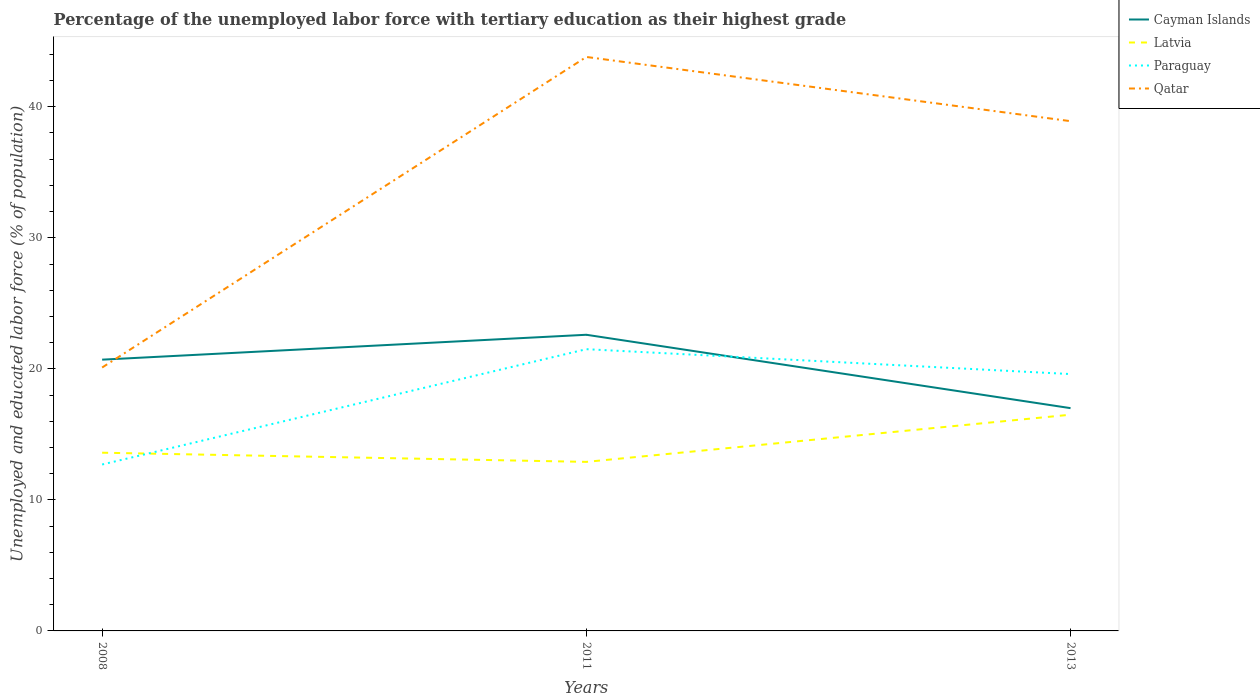Is the number of lines equal to the number of legend labels?
Give a very brief answer. Yes. Across all years, what is the maximum percentage of the unemployed labor force with tertiary education in Paraguay?
Give a very brief answer. 12.7. In which year was the percentage of the unemployed labor force with tertiary education in Cayman Islands maximum?
Offer a terse response. 2013. What is the total percentage of the unemployed labor force with tertiary education in Qatar in the graph?
Make the answer very short. -23.7. What is the difference between the highest and the second highest percentage of the unemployed labor force with tertiary education in Qatar?
Give a very brief answer. 23.7. What is the difference between the highest and the lowest percentage of the unemployed labor force with tertiary education in Latvia?
Your answer should be compact. 1. How many years are there in the graph?
Offer a terse response. 3. What is the difference between two consecutive major ticks on the Y-axis?
Offer a terse response. 10. Are the values on the major ticks of Y-axis written in scientific E-notation?
Offer a terse response. No. Does the graph contain any zero values?
Give a very brief answer. No. How many legend labels are there?
Keep it short and to the point. 4. What is the title of the graph?
Offer a terse response. Percentage of the unemployed labor force with tertiary education as their highest grade. Does "Paraguay" appear as one of the legend labels in the graph?
Keep it short and to the point. Yes. What is the label or title of the Y-axis?
Your answer should be compact. Unemployed and educated labor force (% of population). What is the Unemployed and educated labor force (% of population) in Cayman Islands in 2008?
Your response must be concise. 20.7. What is the Unemployed and educated labor force (% of population) of Latvia in 2008?
Provide a short and direct response. 13.6. What is the Unemployed and educated labor force (% of population) of Paraguay in 2008?
Offer a very short reply. 12.7. What is the Unemployed and educated labor force (% of population) in Qatar in 2008?
Offer a very short reply. 20.1. What is the Unemployed and educated labor force (% of population) in Cayman Islands in 2011?
Ensure brevity in your answer.  22.6. What is the Unemployed and educated labor force (% of population) in Latvia in 2011?
Give a very brief answer. 12.9. What is the Unemployed and educated labor force (% of population) in Qatar in 2011?
Provide a succinct answer. 43.8. What is the Unemployed and educated labor force (% of population) of Cayman Islands in 2013?
Give a very brief answer. 17. What is the Unemployed and educated labor force (% of population) in Latvia in 2013?
Give a very brief answer. 16.5. What is the Unemployed and educated labor force (% of population) of Paraguay in 2013?
Offer a very short reply. 19.6. What is the Unemployed and educated labor force (% of population) in Qatar in 2013?
Ensure brevity in your answer.  38.9. Across all years, what is the maximum Unemployed and educated labor force (% of population) of Cayman Islands?
Give a very brief answer. 22.6. Across all years, what is the maximum Unemployed and educated labor force (% of population) in Latvia?
Offer a terse response. 16.5. Across all years, what is the maximum Unemployed and educated labor force (% of population) in Paraguay?
Your answer should be very brief. 21.5. Across all years, what is the maximum Unemployed and educated labor force (% of population) in Qatar?
Your response must be concise. 43.8. Across all years, what is the minimum Unemployed and educated labor force (% of population) in Latvia?
Provide a succinct answer. 12.9. Across all years, what is the minimum Unemployed and educated labor force (% of population) in Paraguay?
Your response must be concise. 12.7. Across all years, what is the minimum Unemployed and educated labor force (% of population) in Qatar?
Give a very brief answer. 20.1. What is the total Unemployed and educated labor force (% of population) in Cayman Islands in the graph?
Offer a very short reply. 60.3. What is the total Unemployed and educated labor force (% of population) in Latvia in the graph?
Your response must be concise. 43. What is the total Unemployed and educated labor force (% of population) in Paraguay in the graph?
Provide a short and direct response. 53.8. What is the total Unemployed and educated labor force (% of population) of Qatar in the graph?
Give a very brief answer. 102.8. What is the difference between the Unemployed and educated labor force (% of population) in Qatar in 2008 and that in 2011?
Your answer should be compact. -23.7. What is the difference between the Unemployed and educated labor force (% of population) in Cayman Islands in 2008 and that in 2013?
Your response must be concise. 3.7. What is the difference between the Unemployed and educated labor force (% of population) of Paraguay in 2008 and that in 2013?
Give a very brief answer. -6.9. What is the difference between the Unemployed and educated labor force (% of population) of Qatar in 2008 and that in 2013?
Your answer should be very brief. -18.8. What is the difference between the Unemployed and educated labor force (% of population) in Cayman Islands in 2011 and that in 2013?
Give a very brief answer. 5.6. What is the difference between the Unemployed and educated labor force (% of population) of Latvia in 2011 and that in 2013?
Ensure brevity in your answer.  -3.6. What is the difference between the Unemployed and educated labor force (% of population) of Paraguay in 2011 and that in 2013?
Give a very brief answer. 1.9. What is the difference between the Unemployed and educated labor force (% of population) of Cayman Islands in 2008 and the Unemployed and educated labor force (% of population) of Paraguay in 2011?
Ensure brevity in your answer.  -0.8. What is the difference between the Unemployed and educated labor force (% of population) in Cayman Islands in 2008 and the Unemployed and educated labor force (% of population) in Qatar in 2011?
Your response must be concise. -23.1. What is the difference between the Unemployed and educated labor force (% of population) in Latvia in 2008 and the Unemployed and educated labor force (% of population) in Paraguay in 2011?
Keep it short and to the point. -7.9. What is the difference between the Unemployed and educated labor force (% of population) of Latvia in 2008 and the Unemployed and educated labor force (% of population) of Qatar in 2011?
Offer a terse response. -30.2. What is the difference between the Unemployed and educated labor force (% of population) in Paraguay in 2008 and the Unemployed and educated labor force (% of population) in Qatar in 2011?
Give a very brief answer. -31.1. What is the difference between the Unemployed and educated labor force (% of population) in Cayman Islands in 2008 and the Unemployed and educated labor force (% of population) in Paraguay in 2013?
Provide a short and direct response. 1.1. What is the difference between the Unemployed and educated labor force (% of population) in Cayman Islands in 2008 and the Unemployed and educated labor force (% of population) in Qatar in 2013?
Your answer should be very brief. -18.2. What is the difference between the Unemployed and educated labor force (% of population) in Latvia in 2008 and the Unemployed and educated labor force (% of population) in Paraguay in 2013?
Offer a very short reply. -6. What is the difference between the Unemployed and educated labor force (% of population) of Latvia in 2008 and the Unemployed and educated labor force (% of population) of Qatar in 2013?
Make the answer very short. -25.3. What is the difference between the Unemployed and educated labor force (% of population) in Paraguay in 2008 and the Unemployed and educated labor force (% of population) in Qatar in 2013?
Offer a very short reply. -26.2. What is the difference between the Unemployed and educated labor force (% of population) in Cayman Islands in 2011 and the Unemployed and educated labor force (% of population) in Latvia in 2013?
Offer a terse response. 6.1. What is the difference between the Unemployed and educated labor force (% of population) of Cayman Islands in 2011 and the Unemployed and educated labor force (% of population) of Paraguay in 2013?
Your answer should be very brief. 3. What is the difference between the Unemployed and educated labor force (% of population) of Cayman Islands in 2011 and the Unemployed and educated labor force (% of population) of Qatar in 2013?
Ensure brevity in your answer.  -16.3. What is the difference between the Unemployed and educated labor force (% of population) of Latvia in 2011 and the Unemployed and educated labor force (% of population) of Paraguay in 2013?
Give a very brief answer. -6.7. What is the difference between the Unemployed and educated labor force (% of population) of Latvia in 2011 and the Unemployed and educated labor force (% of population) of Qatar in 2013?
Ensure brevity in your answer.  -26. What is the difference between the Unemployed and educated labor force (% of population) of Paraguay in 2011 and the Unemployed and educated labor force (% of population) of Qatar in 2013?
Offer a terse response. -17.4. What is the average Unemployed and educated labor force (% of population) of Cayman Islands per year?
Your response must be concise. 20.1. What is the average Unemployed and educated labor force (% of population) in Latvia per year?
Keep it short and to the point. 14.33. What is the average Unemployed and educated labor force (% of population) of Paraguay per year?
Give a very brief answer. 17.93. What is the average Unemployed and educated labor force (% of population) of Qatar per year?
Offer a very short reply. 34.27. In the year 2011, what is the difference between the Unemployed and educated labor force (% of population) in Cayman Islands and Unemployed and educated labor force (% of population) in Latvia?
Ensure brevity in your answer.  9.7. In the year 2011, what is the difference between the Unemployed and educated labor force (% of population) in Cayman Islands and Unemployed and educated labor force (% of population) in Paraguay?
Provide a short and direct response. 1.1. In the year 2011, what is the difference between the Unemployed and educated labor force (% of population) in Cayman Islands and Unemployed and educated labor force (% of population) in Qatar?
Your answer should be compact. -21.2. In the year 2011, what is the difference between the Unemployed and educated labor force (% of population) of Latvia and Unemployed and educated labor force (% of population) of Paraguay?
Your response must be concise. -8.6. In the year 2011, what is the difference between the Unemployed and educated labor force (% of population) of Latvia and Unemployed and educated labor force (% of population) of Qatar?
Provide a succinct answer. -30.9. In the year 2011, what is the difference between the Unemployed and educated labor force (% of population) of Paraguay and Unemployed and educated labor force (% of population) of Qatar?
Offer a terse response. -22.3. In the year 2013, what is the difference between the Unemployed and educated labor force (% of population) of Cayman Islands and Unemployed and educated labor force (% of population) of Paraguay?
Provide a short and direct response. -2.6. In the year 2013, what is the difference between the Unemployed and educated labor force (% of population) in Cayman Islands and Unemployed and educated labor force (% of population) in Qatar?
Offer a very short reply. -21.9. In the year 2013, what is the difference between the Unemployed and educated labor force (% of population) of Latvia and Unemployed and educated labor force (% of population) of Paraguay?
Make the answer very short. -3.1. In the year 2013, what is the difference between the Unemployed and educated labor force (% of population) in Latvia and Unemployed and educated labor force (% of population) in Qatar?
Make the answer very short. -22.4. In the year 2013, what is the difference between the Unemployed and educated labor force (% of population) of Paraguay and Unemployed and educated labor force (% of population) of Qatar?
Keep it short and to the point. -19.3. What is the ratio of the Unemployed and educated labor force (% of population) in Cayman Islands in 2008 to that in 2011?
Your answer should be compact. 0.92. What is the ratio of the Unemployed and educated labor force (% of population) of Latvia in 2008 to that in 2011?
Offer a terse response. 1.05. What is the ratio of the Unemployed and educated labor force (% of population) of Paraguay in 2008 to that in 2011?
Offer a terse response. 0.59. What is the ratio of the Unemployed and educated labor force (% of population) of Qatar in 2008 to that in 2011?
Offer a terse response. 0.46. What is the ratio of the Unemployed and educated labor force (% of population) in Cayman Islands in 2008 to that in 2013?
Provide a short and direct response. 1.22. What is the ratio of the Unemployed and educated labor force (% of population) of Latvia in 2008 to that in 2013?
Offer a very short reply. 0.82. What is the ratio of the Unemployed and educated labor force (% of population) in Paraguay in 2008 to that in 2013?
Keep it short and to the point. 0.65. What is the ratio of the Unemployed and educated labor force (% of population) in Qatar in 2008 to that in 2013?
Your response must be concise. 0.52. What is the ratio of the Unemployed and educated labor force (% of population) of Cayman Islands in 2011 to that in 2013?
Provide a succinct answer. 1.33. What is the ratio of the Unemployed and educated labor force (% of population) in Latvia in 2011 to that in 2013?
Give a very brief answer. 0.78. What is the ratio of the Unemployed and educated labor force (% of population) in Paraguay in 2011 to that in 2013?
Give a very brief answer. 1.1. What is the ratio of the Unemployed and educated labor force (% of population) in Qatar in 2011 to that in 2013?
Give a very brief answer. 1.13. What is the difference between the highest and the second highest Unemployed and educated labor force (% of population) in Paraguay?
Your response must be concise. 1.9. What is the difference between the highest and the lowest Unemployed and educated labor force (% of population) of Qatar?
Keep it short and to the point. 23.7. 